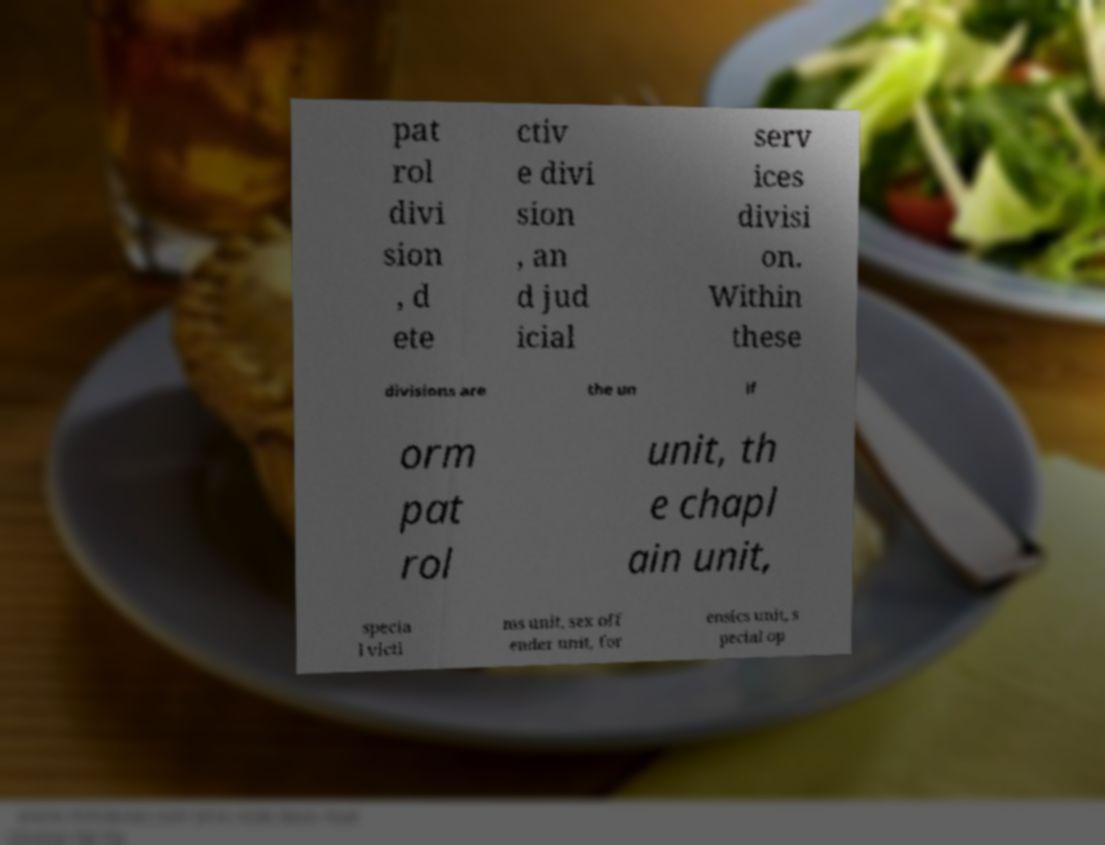For documentation purposes, I need the text within this image transcribed. Could you provide that? pat rol divi sion , d ete ctiv e divi sion , an d jud icial serv ices divisi on. Within these divisions are the un if orm pat rol unit, th e chapl ain unit, specia l victi ms unit, sex off ender unit, for ensics unit, s pecial op 